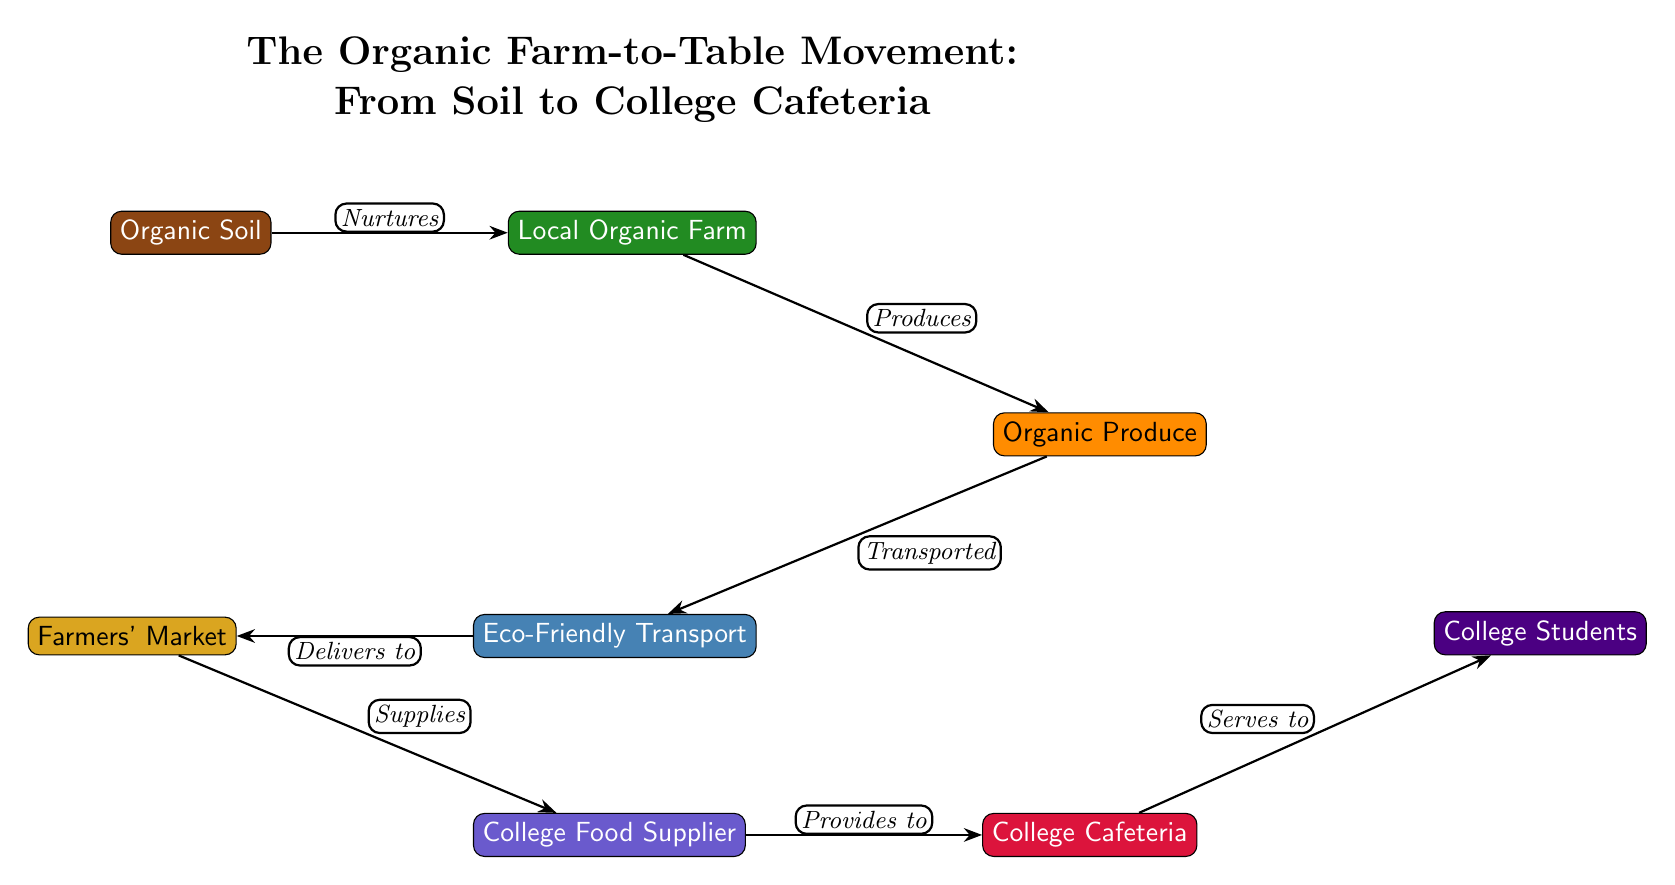What is the first node in the diagram? The first node is labeled "Organic Soil," which is positioned at the top left of the diagram.
Answer: Organic Soil How many nodes are there in total? By counting each labeled node in the diagram, we find there are seven distinct nodes present.
Answer: 7 What relationship exists between the farm and organic produce? The diagram indicates that the farm produces organic produce, as noted by the edge labeled "Produces."
Answer: Produces Which node serves to college students? The diagram shows that the final node, labeled "College Cafeteria," serves to college students, as indicated by the edge labeled "Serves to."
Answer: College Cafeteria What type of transport is used in this movement? The node indicates "Eco-Friendly Transport," specifying the nature of transportation in this food chain.
Answer: Eco-Friendly Transport What is the connection between market and college food supplier? The diagram highlights that the market supplies the college food supplier, detailed by the edge labeled "Supplies."
Answer: Supplies Which node is directly connected to the organic soil? The node directly connected to organic soil is the local organic farm, indicated by the edge labeled "Nurtures."
Answer: Local Organic Farm What is transported from the produce node? The diagram defines that the organic produce is transported, denoted by the label "Transported."
Answer: Organic Produce What is the overall theme of the diagram? The title of the diagram describes it as "The Organic Farm-to-Table Movement: From Soil to College Cafeteria," clearly defining its theme.
Answer: The Organic Farm-to-Table Movement 